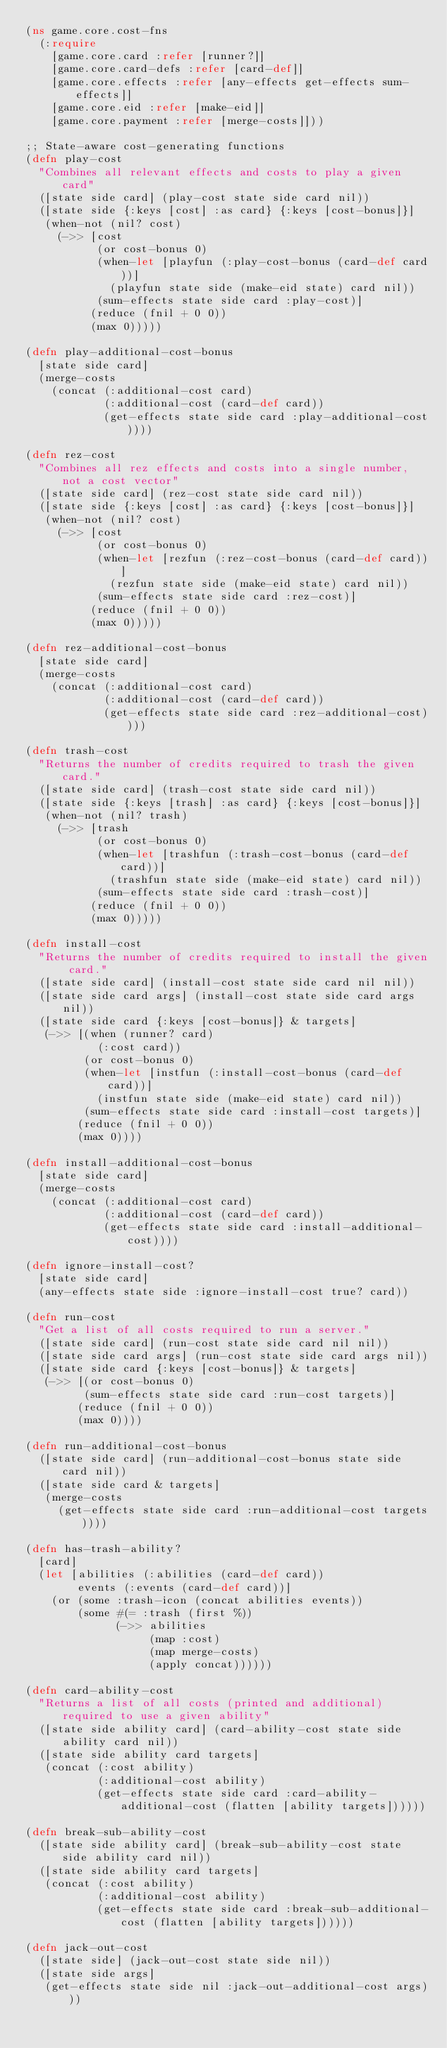Convert code to text. <code><loc_0><loc_0><loc_500><loc_500><_Clojure_>(ns game.core.cost-fns
  (:require
    [game.core.card :refer [runner?]]
    [game.core.card-defs :refer [card-def]]
    [game.core.effects :refer [any-effects get-effects sum-effects]]
    [game.core.eid :refer [make-eid]]
    [game.core.payment :refer [merge-costs]]))

;; State-aware cost-generating functions
(defn play-cost
  "Combines all relevant effects and costs to play a given card"
  ([state side card] (play-cost state side card nil))
  ([state side {:keys [cost] :as card} {:keys [cost-bonus]}]
   (when-not (nil? cost)
     (->> [cost
           (or cost-bonus 0)
           (when-let [playfun (:play-cost-bonus (card-def card))]
             (playfun state side (make-eid state) card nil))
           (sum-effects state side card :play-cost)]
          (reduce (fnil + 0 0))
          (max 0)))))

(defn play-additional-cost-bonus
  [state side card]
  (merge-costs
    (concat (:additional-cost card)
            (:additional-cost (card-def card))
            (get-effects state side card :play-additional-cost))))

(defn rez-cost
  "Combines all rez effects and costs into a single number, not a cost vector"
  ([state side card] (rez-cost state side card nil))
  ([state side {:keys [cost] :as card} {:keys [cost-bonus]}]
   (when-not (nil? cost)
     (->> [cost
           (or cost-bonus 0)
           (when-let [rezfun (:rez-cost-bonus (card-def card))]
             (rezfun state side (make-eid state) card nil))
           (sum-effects state side card :rez-cost)]
          (reduce (fnil + 0 0))
          (max 0)))))

(defn rez-additional-cost-bonus
  [state side card]
  (merge-costs
    (concat (:additional-cost card)
            (:additional-cost (card-def card))
            (get-effects state side card :rez-additional-cost))))

(defn trash-cost
  "Returns the number of credits required to trash the given card."
  ([state side card] (trash-cost state side card nil))
  ([state side {:keys [trash] :as card} {:keys [cost-bonus]}]
   (when-not (nil? trash)
     (->> [trash
           (or cost-bonus 0)
           (when-let [trashfun (:trash-cost-bonus (card-def card))]
             (trashfun state side (make-eid state) card nil))
           (sum-effects state side card :trash-cost)]
          (reduce (fnil + 0 0))
          (max 0)))))

(defn install-cost
  "Returns the number of credits required to install the given card."
  ([state side card] (install-cost state side card nil nil))
  ([state side card args] (install-cost state side card args nil))
  ([state side card {:keys [cost-bonus]} & targets]
   (->> [(when (runner? card)
           (:cost card))
         (or cost-bonus 0)
         (when-let [instfun (:install-cost-bonus (card-def card))]
           (instfun state side (make-eid state) card nil))
         (sum-effects state side card :install-cost targets)]
        (reduce (fnil + 0 0))
        (max 0))))

(defn install-additional-cost-bonus
  [state side card]
  (merge-costs
    (concat (:additional-cost card)
            (:additional-cost (card-def card))
            (get-effects state side card :install-additional-cost))))

(defn ignore-install-cost?
  [state side card]
  (any-effects state side :ignore-install-cost true? card))

(defn run-cost
  "Get a list of all costs required to run a server."
  ([state side card] (run-cost state side card nil nil))
  ([state side card args] (run-cost state side card args nil))
  ([state side card {:keys [cost-bonus]} & targets]
   (->> [(or cost-bonus 0)
         (sum-effects state side card :run-cost targets)]
        (reduce (fnil + 0 0))
        (max 0))))

(defn run-additional-cost-bonus
  ([state side card] (run-additional-cost-bonus state side card nil))
  ([state side card & targets]
   (merge-costs
     (get-effects state side card :run-additional-cost targets))))

(defn has-trash-ability?
  [card]
  (let [abilities (:abilities (card-def card))
        events (:events (card-def card))]
    (or (some :trash-icon (concat abilities events))
        (some #(= :trash (first %))
              (->> abilities
                   (map :cost)
                   (map merge-costs)
                   (apply concat))))))

(defn card-ability-cost
  "Returns a list of all costs (printed and additional) required to use a given ability"
  ([state side ability card] (card-ability-cost state side ability card nil))
  ([state side ability card targets]
   (concat (:cost ability)
           (:additional-cost ability)
           (get-effects state side card :card-ability-additional-cost (flatten [ability targets])))))

(defn break-sub-ability-cost
  ([state side ability card] (break-sub-ability-cost state side ability card nil))
  ([state side ability card targets]
   (concat (:cost ability)
           (:additional-cost ability)
           (get-effects state side card :break-sub-additional-cost (flatten [ability targets])))))

(defn jack-out-cost
  ([state side] (jack-out-cost state side nil))
  ([state side args]
   (get-effects state side nil :jack-out-additional-cost args)))
</code> 